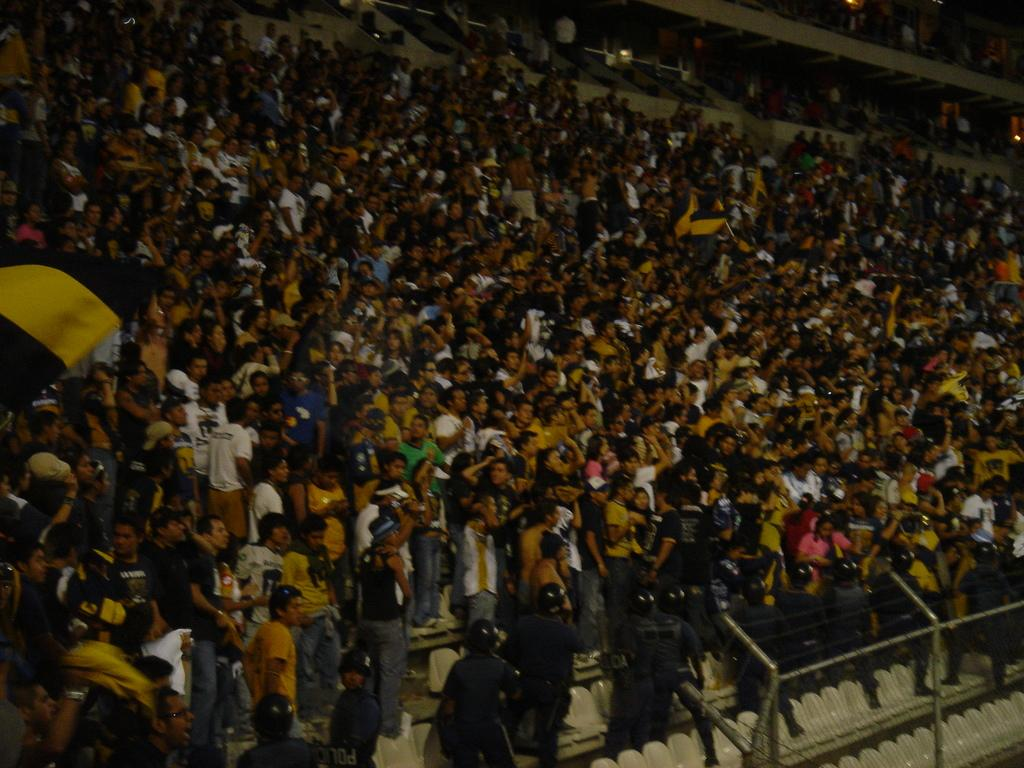What are the persons in the image doing? The persons in the image are on the stairs. What can be seen at the right bottom of the image? There is a fence at the right bottom of the image. What are the persons at the bottom of the image wearing? The persons at the bottom of the image are wearing helmets and jackets. What type of hat is the person wearing at the top of the stairs? There is no person wearing a hat at the top of the stairs in the image. 